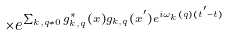<formula> <loc_0><loc_0><loc_500><loc_500>\times e ^ { \sum _ { { k } , { q } \neq 0 } g ^ { * } _ { { k } , { q } } ( { x } ) g _ { { k } , { q } } ( { x } ^ { ^ { \prime } } ) e ^ { i \omega _ { k } ( { q } ) ( t ^ { ^ { \prime } } - t ) } }</formula> 